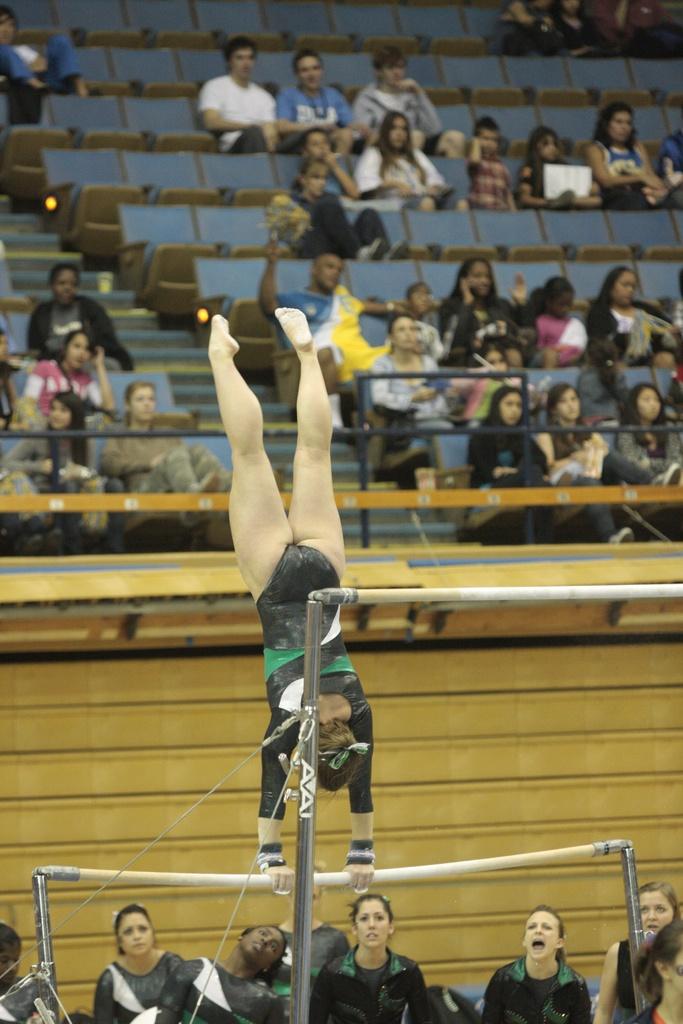What color is the uniform of the girl on the bar?
Keep it short and to the point. Black. 